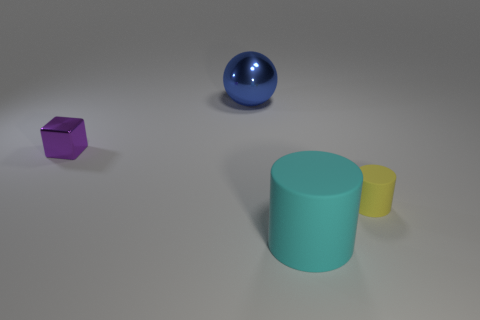Subtract all blocks. How many objects are left? 3 Add 3 small rubber cylinders. How many objects exist? 7 Subtract all big matte balls. Subtract all small purple blocks. How many objects are left? 3 Add 4 yellow cylinders. How many yellow cylinders are left? 5 Add 4 cyan metal things. How many cyan metal things exist? 4 Subtract all cyan cylinders. How many cylinders are left? 1 Subtract 0 cyan blocks. How many objects are left? 4 Subtract all brown balls. Subtract all red cubes. How many balls are left? 1 Subtract all blue cylinders. How many yellow spheres are left? 0 